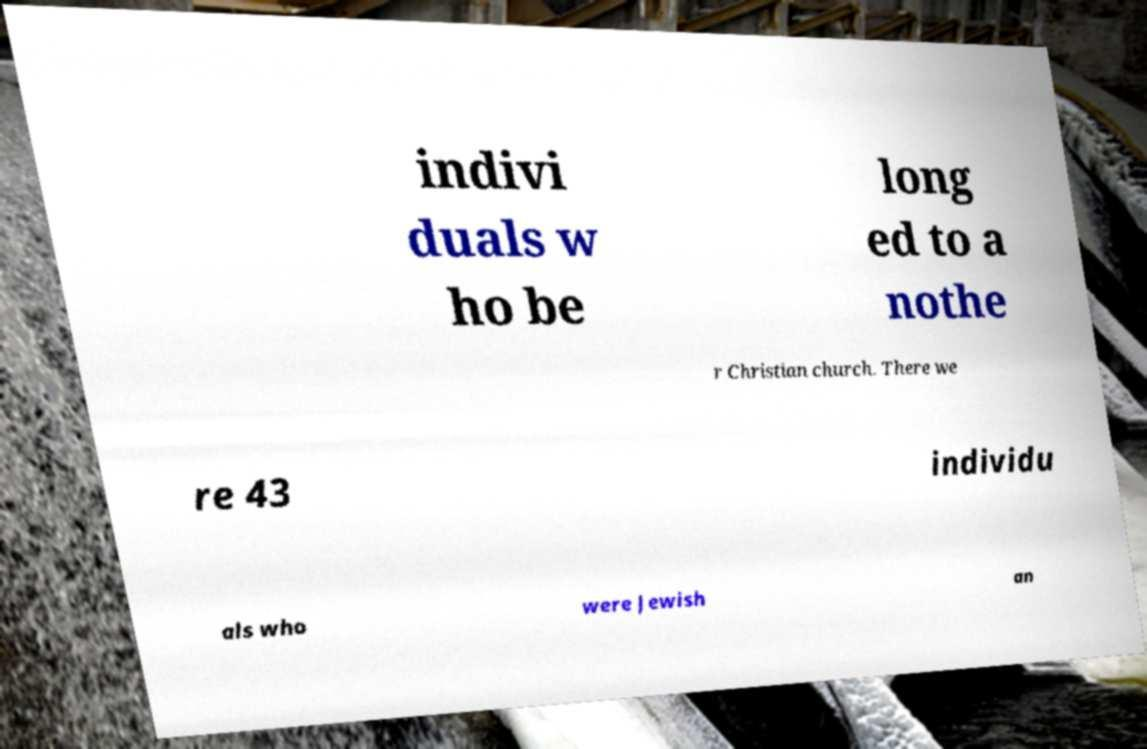Can you accurately transcribe the text from the provided image for me? indivi duals w ho be long ed to a nothe r Christian church. There we re 43 individu als who were Jewish an 